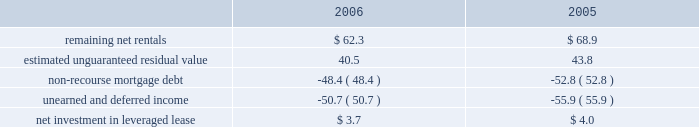Kimco realty corporation and subsidiaries job title kimco realty ar revision 6 serial date / time tuesday , april 03 , 2007 /10:32 pm job number 142704 type current page no .
65 operator pm2 <12345678> at december 31 , 2006 and 2005 , the company 2019s net invest- ment in the leveraged lease consisted of the following ( in mil- lions ) : .
Mortgages and other financing receivables : during january 2006 , the company provided approximately $ 16.0 million as its share of a $ 50.0 million junior participation in a $ 700.0 million first mortgage loan , in connection with a private investment firm 2019s acquisition of a retailer .
This loan participation bore interest at libor plus 7.75% ( 7.75 % ) per annum and had a two-year term with a one-year extension option and was collateralized by certain real estate interests of the retailer .
During june 2006 , the borrower elected to pre-pay the outstanding loan balance of approximately $ 16.0 million in full satisfaction of this loan .
Additionally , during january 2006 , the company provided approximately $ 5.2 million as its share of an $ 11.5 million term loan to a real estate developer for the acquisition of a 59 acre land parcel located in san antonio , tx .
This loan is interest only at a fixed rate of 11.0% ( 11.0 % ) for a term of two years payable monthly and collateralized by a first mortgage on the subject property .
As of december 31 , 2006 , the outstanding balance on this loan was approximately $ 5.2 million .
During february 2006 , the company committed to provide a one year $ 17.2 million credit facility at a fixed rate of 8.0% ( 8.0 % ) for a term of nine months and 9.0% ( 9.0 % ) for the remaining term to a real estate investor for the recapitalization of a discount and entertain- ment mall that it currently owns .
During 2006 , this facility was fully paid and was terminated .
During april 2006 , the company provided two separate mortgages aggregating $ 14.5 million on a property owned by a real estate investor .
Proceeds were used to payoff the existing first mortgage , buyout the existing partner and for redevelopment of the property .
The mortgages bear interest at 8.0% ( 8.0 % ) per annum and mature in 2008 and 2013 .
These mortgages are collateralized by the subject property .
As of december 31 , 2006 , the aggregate outstanding balance on these mortgages was approximately $ 15.0 million , including $ 0.5 million of accrued interest .
During may 2006 , the company provided a cad $ 23.5 million collateralized credit facility at a fixed rate of 8.5% ( 8.5 % ) per annum for a term of two years to a real estate company for the execution of its property acquisitions program .
The credit facility is guaranteed by the real estate company .
The company was issued 9811 units , valued at approximately usd $ 0.1 million , and warrants to purchase up to 0.1 million shares of the real estate company as a loan origination fee .
During august 2006 , the company increased the credit facility to cad $ 45.0 million and received an additional 9811 units , valued at approximately usd $ 0.1 million , and warrants to purchase up to 0.1 million shares of the real estate company .
As of december 31 , 2006 , the outstand- ing balance on this credit facility was approximately cad $ 3.6 million ( approximately usd $ 3.1 million ) .
During september 2005 , a newly formed joint venture , in which the company had an 80% ( 80 % ) interest , acquired a 90% ( 90 % ) interest in a $ 48.4 million mortgage receivable for a purchase price of approximately $ 34.2 million .
This loan bore interest at a rate of three-month libor plus 2.75% ( 2.75 % ) per annum and was scheduled to mature on january 12 , 2010 .
A 626-room hotel located in lake buena vista , fl collateralized the loan .
The company had determined that this joint venture entity was a vie and had further determined that the company was the primary benefici- ary of this vie and had therefore consolidated it for financial reporting purposes .
During march 2006 , the joint venture acquired the remaining 10% ( 10 % ) of this mortgage receivable for a purchase price of approximately $ 3.8 million .
During june 2006 , the joint venture accepted a pre-payment of approximately $ 45.2 million from the borrower as full satisfaction of this loan .
During august 2006 , the company provided $ 8.8 million as its share of a $ 13.2 million 12-month term loan to a retailer for general corporate purposes .
This loan bears interest at a fixed rate of 12.50% ( 12.50 % ) with interest payable monthly and a balloon payment for the principal balance at maturity .
The loan is collateralized by the underlying real estate of the retailer .
Additionally , the company funded $ 13.3 million as its share of a $ 20.0 million revolving debtor-in-possession facility to this retailer .
The facility bears interest at libor plus 3.00% ( 3.00 % ) and has an unused line fee of 0.375% ( 0.375 % ) .
This credit facility is collateralized by a first priority lien on all the retailer 2019s assets .
As of december 31 , 2006 , the compa- ny 2019s share of the outstanding balance on this loan and credit facility was approximately $ 7.6 million and $ 4.9 million , respec- tively .
During september 2006 , the company provided a mxp 57.3 million ( approximately usd $ 5.3 million ) loan to an owner of an operating property in mexico .
The loan , which is collateralized by the property , bears interest at 12.0% ( 12.0 % ) per annum and matures in 2016 .
The company is entitled to a participation feature of 25% ( 25 % ) of annual cash flows after debt service and 20% ( 20 % ) of the gain on sale of the property .
As of december 31 , 2006 , the outstand- ing balance on this loan was approximately mxp 57.8 million ( approximately usd $ 5.3 million ) .
During november 2006 , the company committed to provide a mxp 124.8 million ( approximately usd $ 11.5 million ) loan to an owner of a land parcel in acapulco , mexico .
The loan , which is collateralized with an operating property owned by the bor- rower , bears interest at 10% ( 10 % ) per annum and matures in 2016 .
The company is entitled to a participation feature of 20% ( 20 % ) of excess cash flows and gains on sale of the property .
As of decem- ber 31 , 2006 , the outstanding balance on this loan was mxp 12.8 million ( approximately usd $ 1.2 million ) . .
What is the yearly interest income generated by the collateralized credit facility provided to the real estate company for the execution of its property acquisitions program , in million cad? 
Computations: (23.5 * 8.5%)
Answer: 1.9975. 